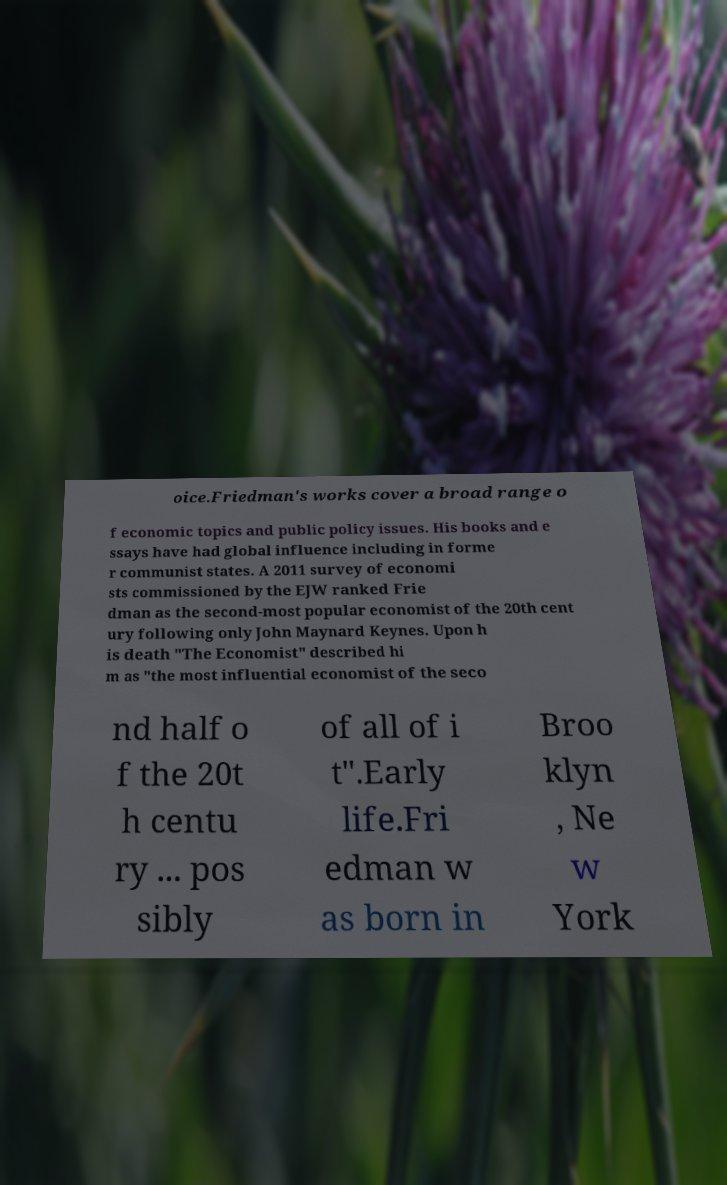Could you assist in decoding the text presented in this image and type it out clearly? oice.Friedman's works cover a broad range o f economic topics and public policy issues. His books and e ssays have had global influence including in forme r communist states. A 2011 survey of economi sts commissioned by the EJW ranked Frie dman as the second-most popular economist of the 20th cent ury following only John Maynard Keynes. Upon h is death "The Economist" described hi m as "the most influential economist of the seco nd half o f the 20t h centu ry ... pos sibly of all of i t".Early life.Fri edman w as born in Broo klyn , Ne w York 